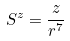Convert formula to latex. <formula><loc_0><loc_0><loc_500><loc_500>S ^ { z } = \frac { z } { r ^ { 7 } }</formula> 